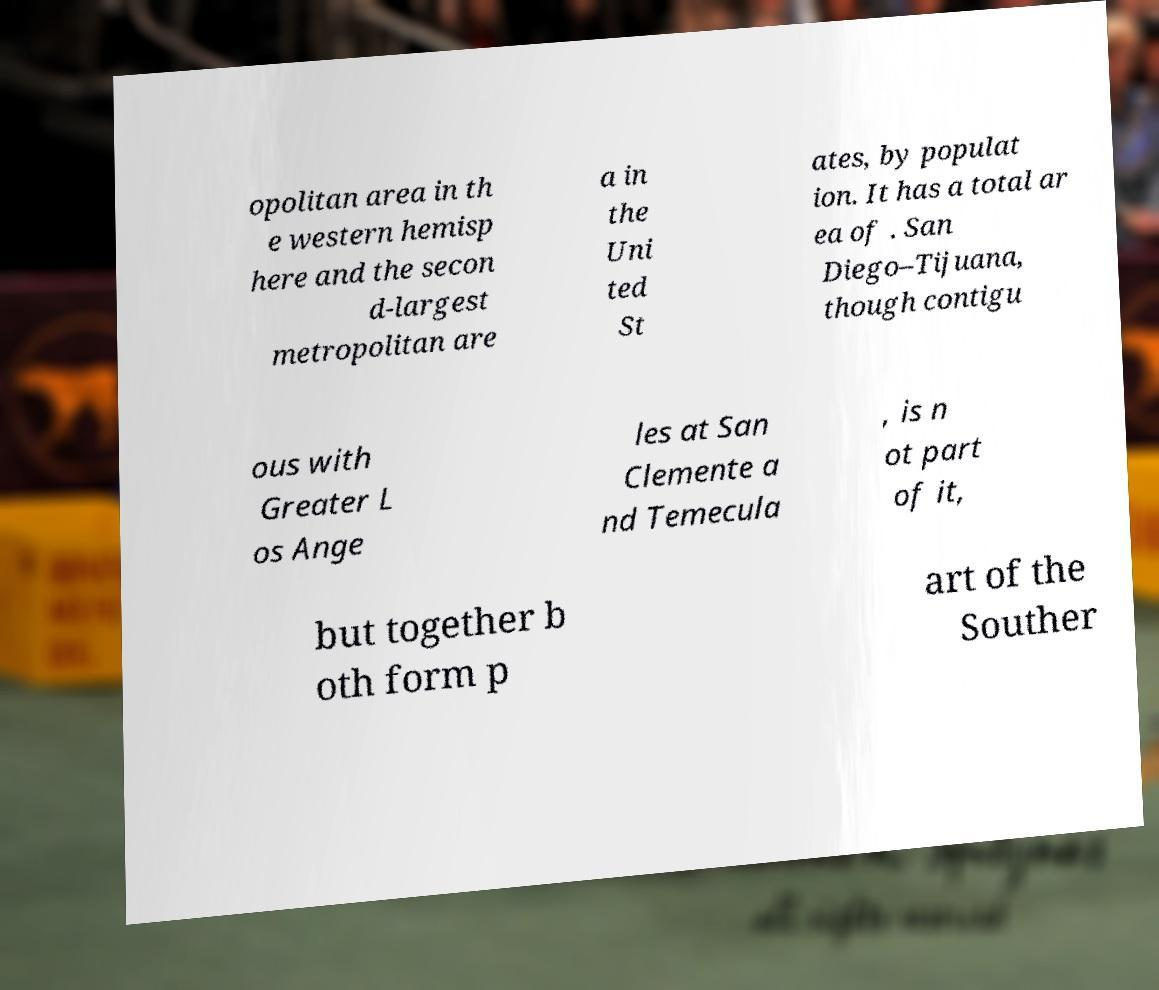Can you read and provide the text displayed in the image?This photo seems to have some interesting text. Can you extract and type it out for me? opolitan area in th e western hemisp here and the secon d-largest metropolitan are a in the Uni ted St ates, by populat ion. It has a total ar ea of . San Diego–Tijuana, though contigu ous with Greater L os Ange les at San Clemente a nd Temecula , is n ot part of it, but together b oth form p art of the Souther 